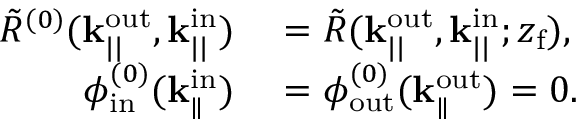Convert formula to latex. <formula><loc_0><loc_0><loc_500><loc_500>\begin{array} { r l } { \tilde { R } ^ { ( 0 ) } ( k _ { | | } ^ { o u t } , k _ { | | } ^ { i n } ) } & = \tilde { R } ( k _ { | | } ^ { o u t } , k _ { | | } ^ { i n } ; z _ { f } ) , } \\ { \phi _ { i n } ^ { ( 0 ) } ( k _ { \| } ^ { i n } ) } & = \phi _ { o u t } ^ { ( 0 ) } ( k _ { \| } ^ { o u t } ) = 0 . } \end{array}</formula> 